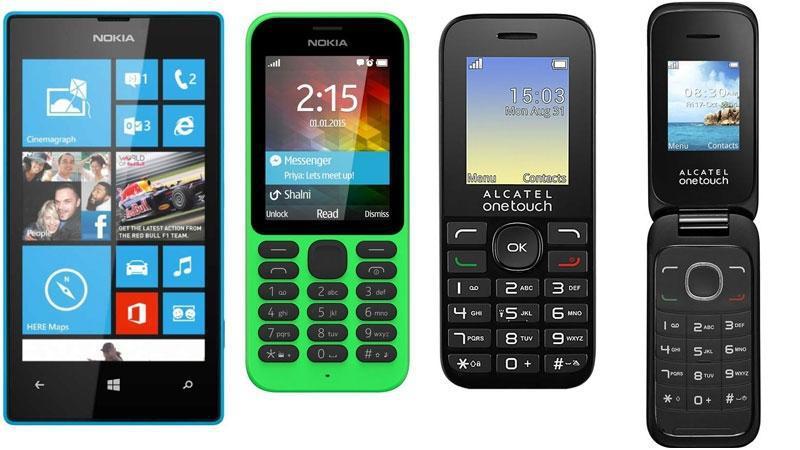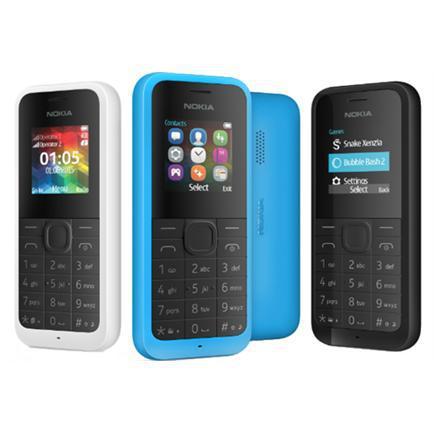The first image is the image on the left, the second image is the image on the right. For the images shown, is this caption "Each image includes at least three 'extra' handsets resting in their bases and at least one main handset on a larger base." true? Answer yes or no. No. The first image is the image on the left, the second image is the image on the right. Analyze the images presented: Is the assertion "There are four phones with at least one red phone." valid? Answer yes or no. No. 